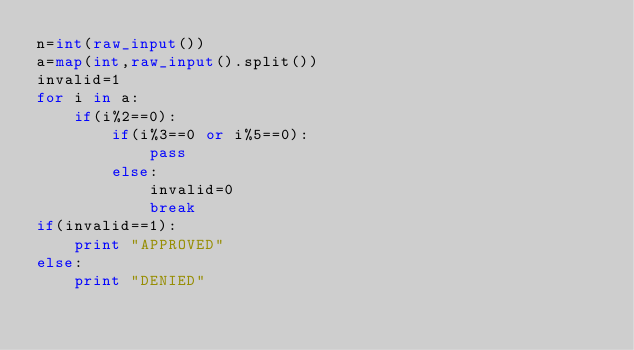<code> <loc_0><loc_0><loc_500><loc_500><_Python_>n=int(raw_input())
a=map(int,raw_input().split())
invalid=1
for i in a:
    if(i%2==0):
        if(i%3==0 or i%5==0):
            pass
        else:
            invalid=0
            break
if(invalid==1):
    print "APPROVED"
else:
    print "DENIED"</code> 